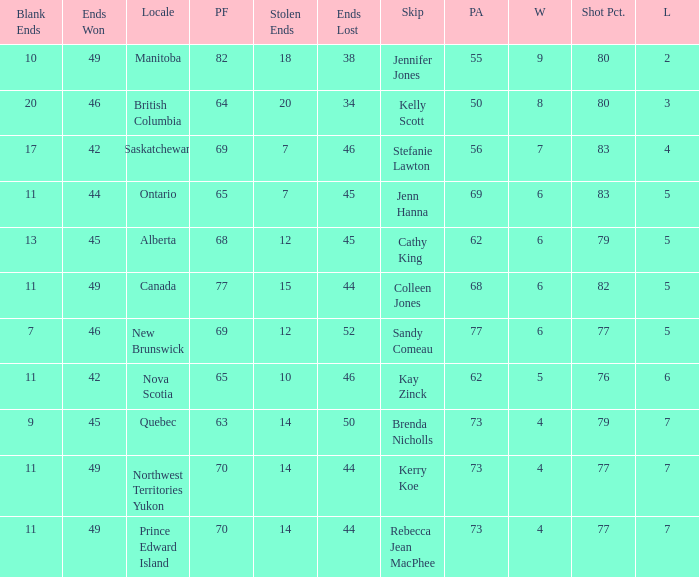What is the lowest PF? 63.0. 